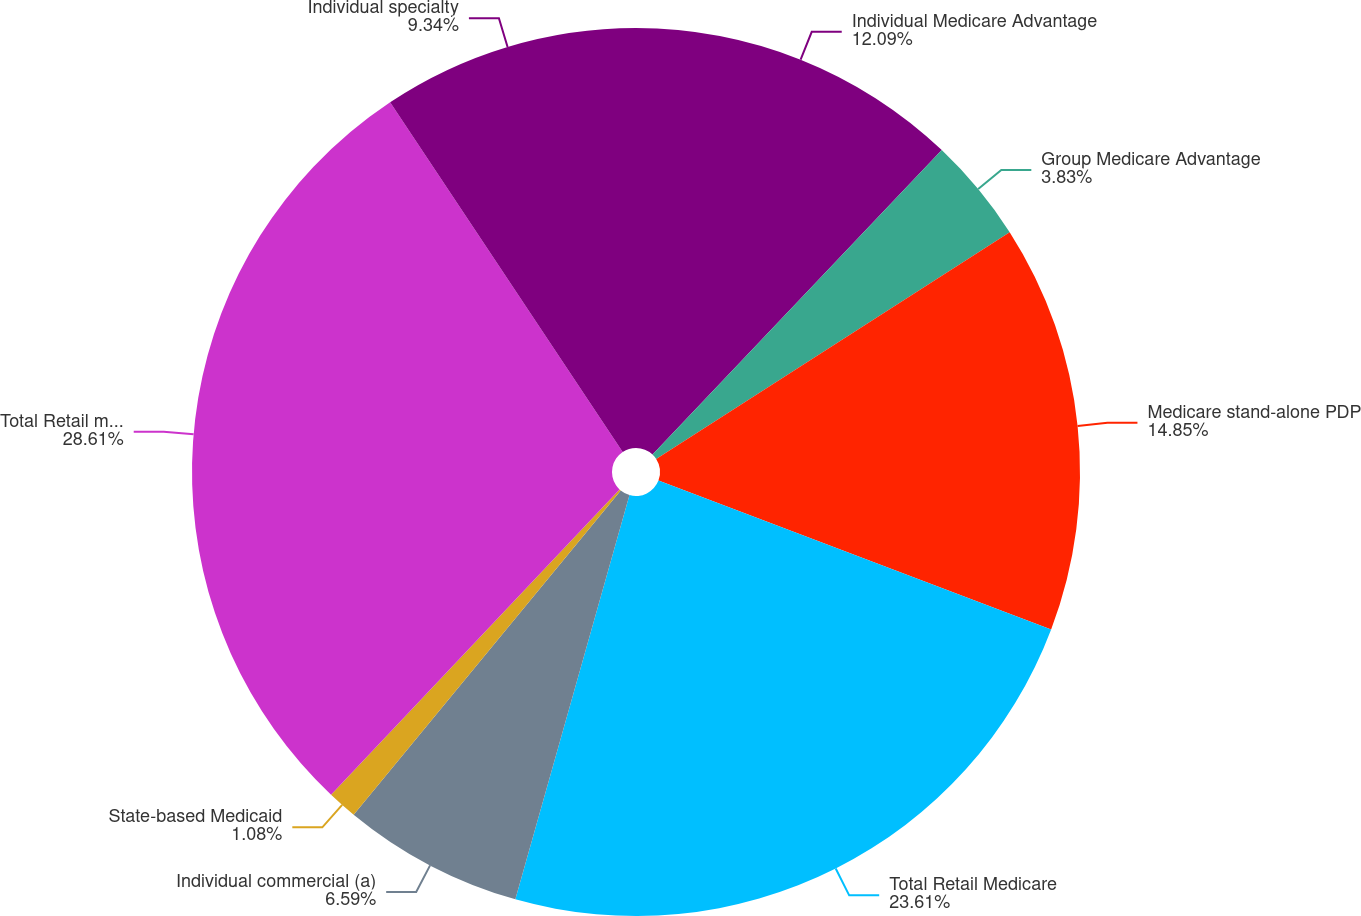Convert chart to OTSL. <chart><loc_0><loc_0><loc_500><loc_500><pie_chart><fcel>Individual Medicare Advantage<fcel>Group Medicare Advantage<fcel>Medicare stand-alone PDP<fcel>Total Retail Medicare<fcel>Individual commercial (a)<fcel>State-based Medicaid<fcel>Total Retail medical members<fcel>Individual specialty<nl><fcel>12.09%<fcel>3.83%<fcel>14.85%<fcel>23.61%<fcel>6.59%<fcel>1.08%<fcel>28.61%<fcel>9.34%<nl></chart> 